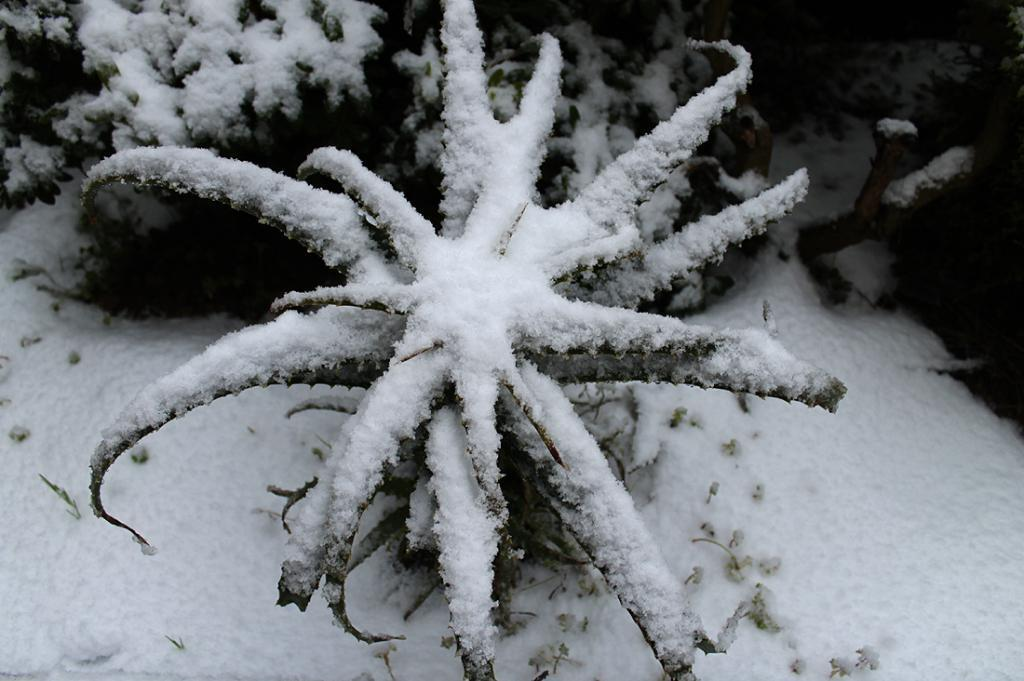What is present in the image? There is a plant in the image. How is the plant affected by the weather or environment? The plant is covered with snow. How many dimes are visible on the plant in the image? There are no dimes visible on the plant in the image. What type of activity is the plant engaged in during the snowfall? Plants do not engage in activities; they are inanimate objects. 